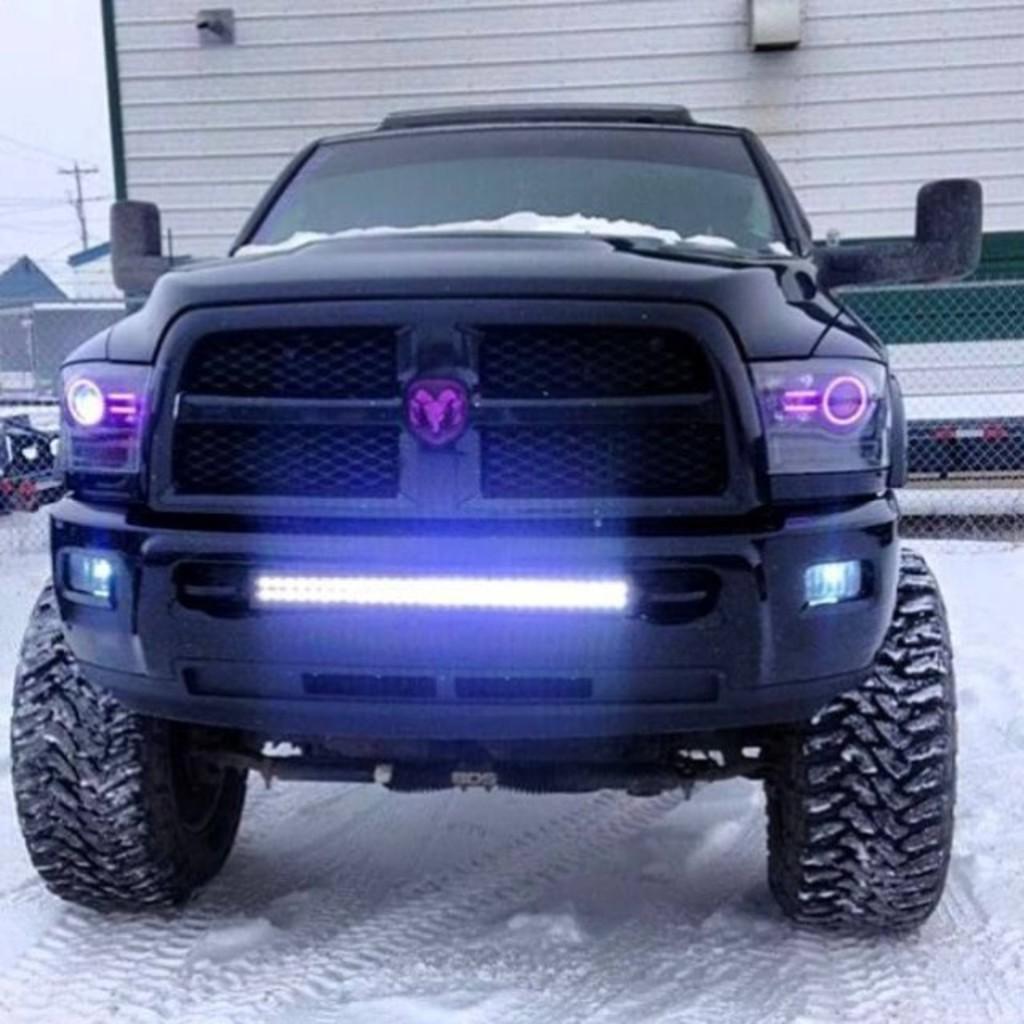Please provide a concise description of this image. In the center of the image we can see a vehicle. In the background of the image we can see a house, shutter, mesh, vehicles, pole, wires. In the top left corner we can see the sky. At the bottom of the image we can see the snow. 